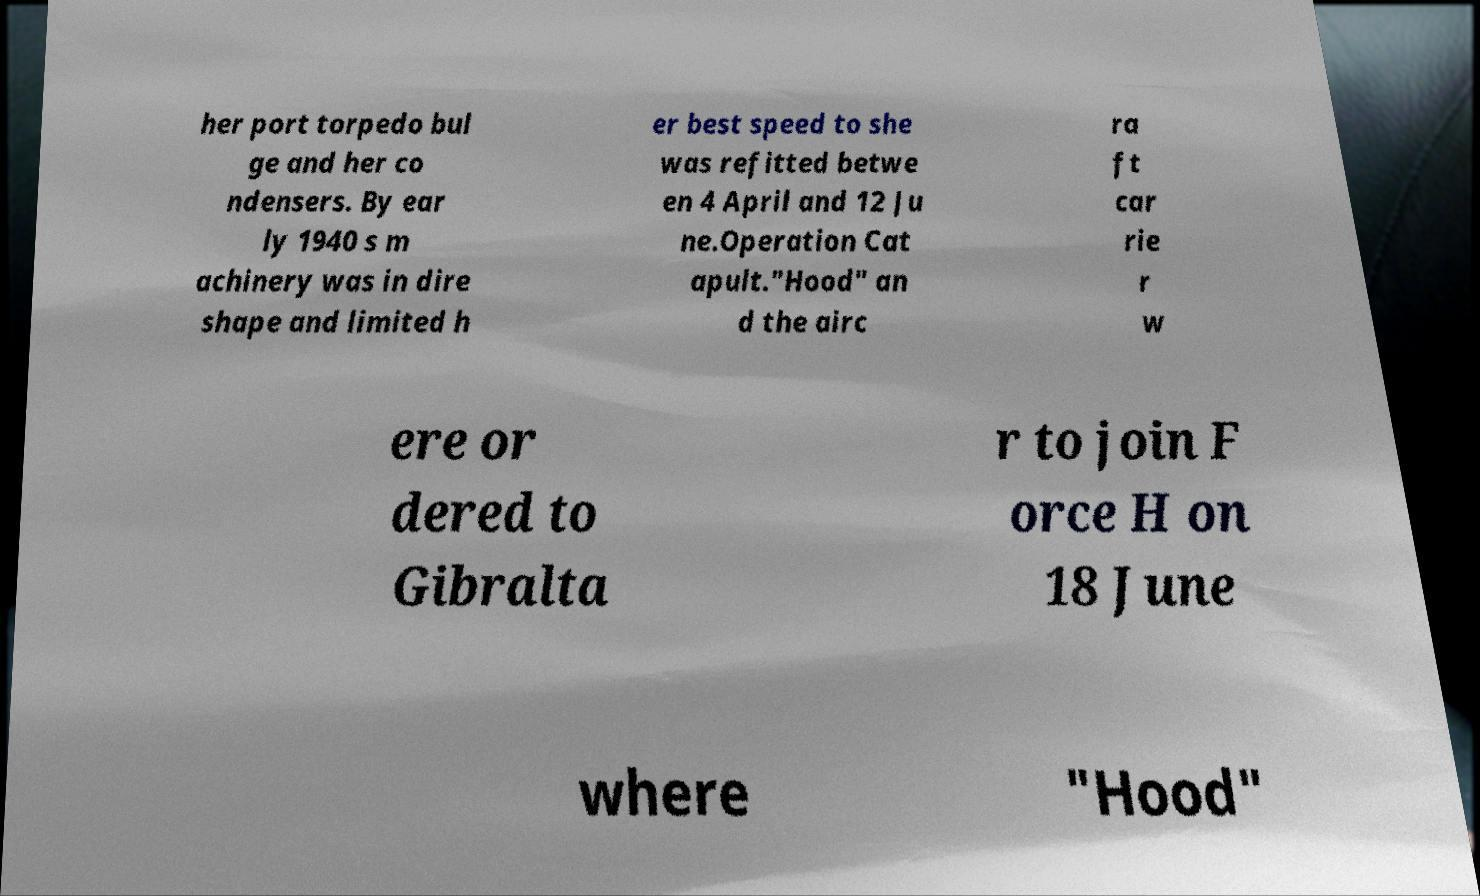Can you accurately transcribe the text from the provided image for me? her port torpedo bul ge and her co ndensers. By ear ly 1940 s m achinery was in dire shape and limited h er best speed to she was refitted betwe en 4 April and 12 Ju ne.Operation Cat apult."Hood" an d the airc ra ft car rie r w ere or dered to Gibralta r to join F orce H on 18 June where "Hood" 